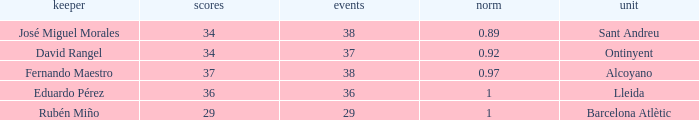What is the sum of Goals, when Matches is less than 29? None. 